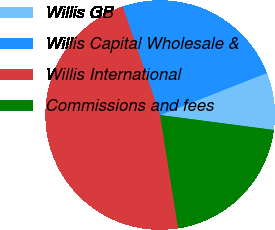<chart> <loc_0><loc_0><loc_500><loc_500><pie_chart><fcel>Willis GB<fcel>Willis Capital Wholesale &<fcel>Willis International<fcel>Commissions and fees<nl><fcel>8.05%<fcel>24.32%<fcel>47.24%<fcel>20.4%<nl></chart> 